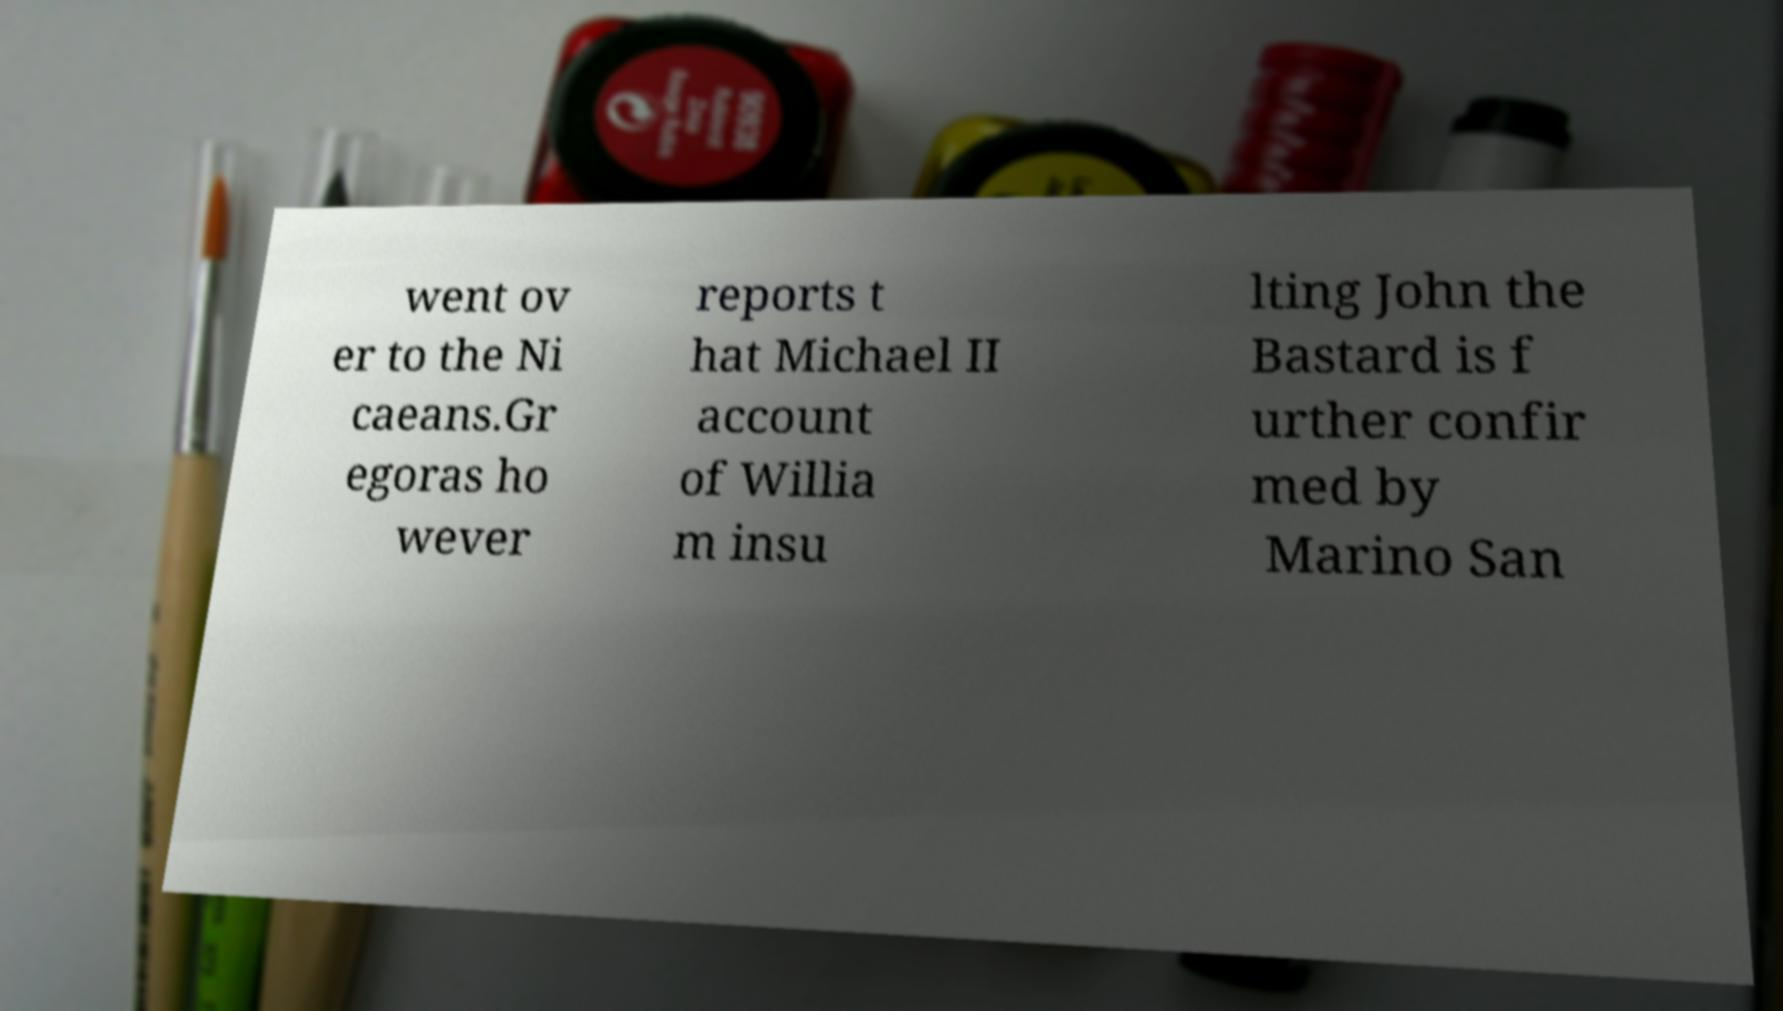Can you read and provide the text displayed in the image?This photo seems to have some interesting text. Can you extract and type it out for me? went ov er to the Ni caeans.Gr egoras ho wever reports t hat Michael II account of Willia m insu lting John the Bastard is f urther confir med by Marino San 